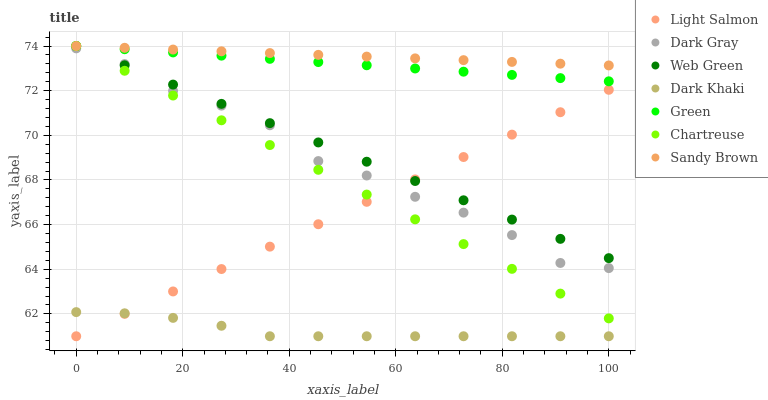Does Dark Khaki have the minimum area under the curve?
Answer yes or no. Yes. Does Sandy Brown have the maximum area under the curve?
Answer yes or no. Yes. Does Light Salmon have the minimum area under the curve?
Answer yes or no. No. Does Light Salmon have the maximum area under the curve?
Answer yes or no. No. Is Light Salmon the smoothest?
Answer yes or no. Yes. Is Dark Gray the roughest?
Answer yes or no. Yes. Is Web Green the smoothest?
Answer yes or no. No. Is Web Green the roughest?
Answer yes or no. No. Does Dark Khaki have the lowest value?
Answer yes or no. Yes. Does Web Green have the lowest value?
Answer yes or no. No. Does Sandy Brown have the highest value?
Answer yes or no. Yes. Does Light Salmon have the highest value?
Answer yes or no. No. Is Dark Khaki less than Web Green?
Answer yes or no. Yes. Is Sandy Brown greater than Dark Khaki?
Answer yes or no. Yes. Does Web Green intersect Sandy Brown?
Answer yes or no. Yes. Is Web Green less than Sandy Brown?
Answer yes or no. No. Is Web Green greater than Sandy Brown?
Answer yes or no. No. Does Dark Khaki intersect Web Green?
Answer yes or no. No. 